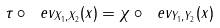<formula> <loc_0><loc_0><loc_500><loc_500>\tau \circ \ e v _ { X _ { 1 } , X _ { 2 } } ( x ) = \chi \circ \ e v _ { Y _ { 1 } , Y _ { 2 } } ( x )</formula> 